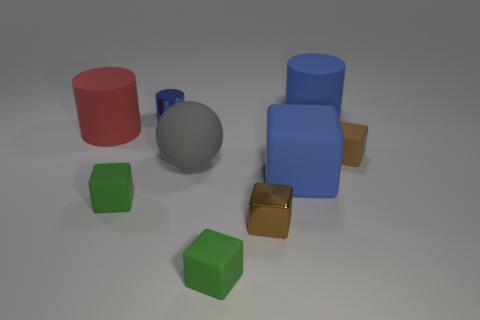What is the role of lighting in how we perceive the colors and textures of these objects? The lighting plays a crucial role in perceiving the colors and textures of these objects. Strong lighting can highlight the texture and glossiness of surfaces, making colors appear more vivid and enhancing visual learning. 